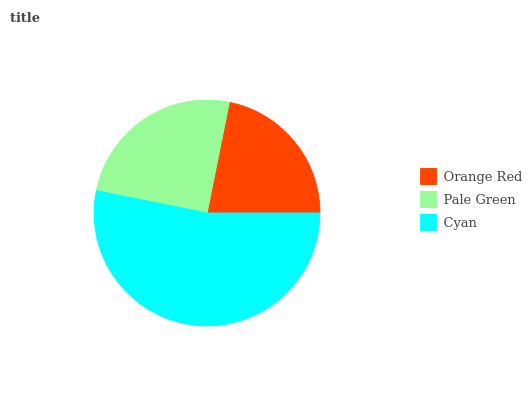Is Orange Red the minimum?
Answer yes or no. Yes. Is Cyan the maximum?
Answer yes or no. Yes. Is Pale Green the minimum?
Answer yes or no. No. Is Pale Green the maximum?
Answer yes or no. No. Is Pale Green greater than Orange Red?
Answer yes or no. Yes. Is Orange Red less than Pale Green?
Answer yes or no. Yes. Is Orange Red greater than Pale Green?
Answer yes or no. No. Is Pale Green less than Orange Red?
Answer yes or no. No. Is Pale Green the high median?
Answer yes or no. Yes. Is Pale Green the low median?
Answer yes or no. Yes. Is Orange Red the high median?
Answer yes or no. No. Is Cyan the low median?
Answer yes or no. No. 